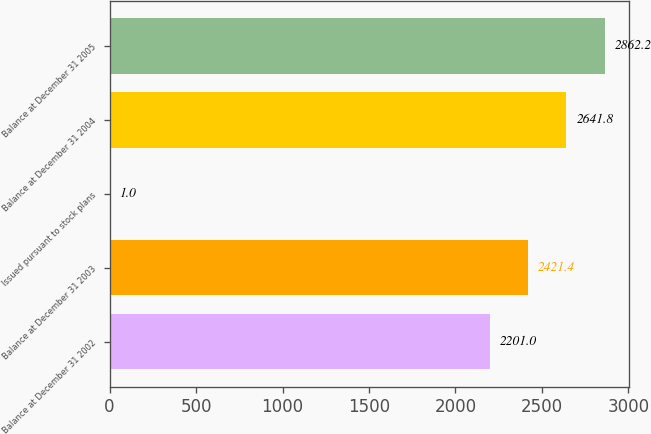<chart> <loc_0><loc_0><loc_500><loc_500><bar_chart><fcel>Balance at December 31 2002<fcel>Balance at December 31 2003<fcel>Issued pursuant to stock plans<fcel>Balance at December 31 2004<fcel>Balance at December 31 2005<nl><fcel>2201<fcel>2421.4<fcel>1<fcel>2641.8<fcel>2862.2<nl></chart> 